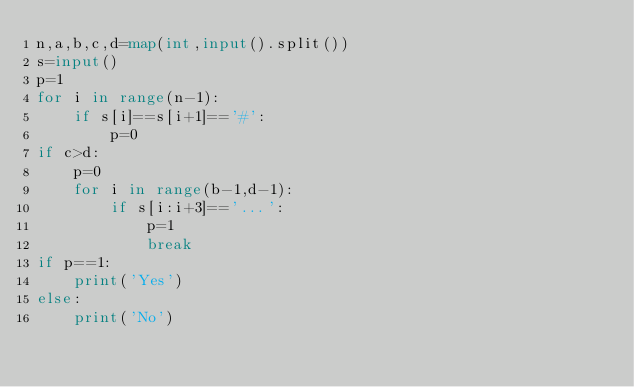Convert code to text. <code><loc_0><loc_0><loc_500><loc_500><_Python_>n,a,b,c,d=map(int,input().split())
s=input()
p=1
for i in range(n-1):
    if s[i]==s[i+1]=='#':
        p=0
if c>d:
    p=0
    for i in range(b-1,d-1):
        if s[i:i+3]=='...':
            p=1
            break
if p==1:
    print('Yes')
else:
    print('No')
</code> 